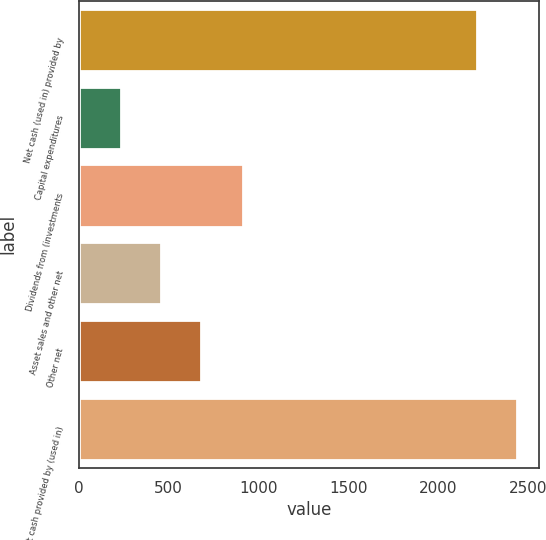<chart> <loc_0><loc_0><loc_500><loc_500><bar_chart><fcel>Net cash (used in) provided by<fcel>Capital expenditures<fcel>Dividends from (investments<fcel>Asset sales and other net<fcel>Other net<fcel>Net cash provided by (used in)<nl><fcel>2217<fcel>234.7<fcel>913<fcel>456.4<fcel>678.1<fcel>2438.7<nl></chart> 